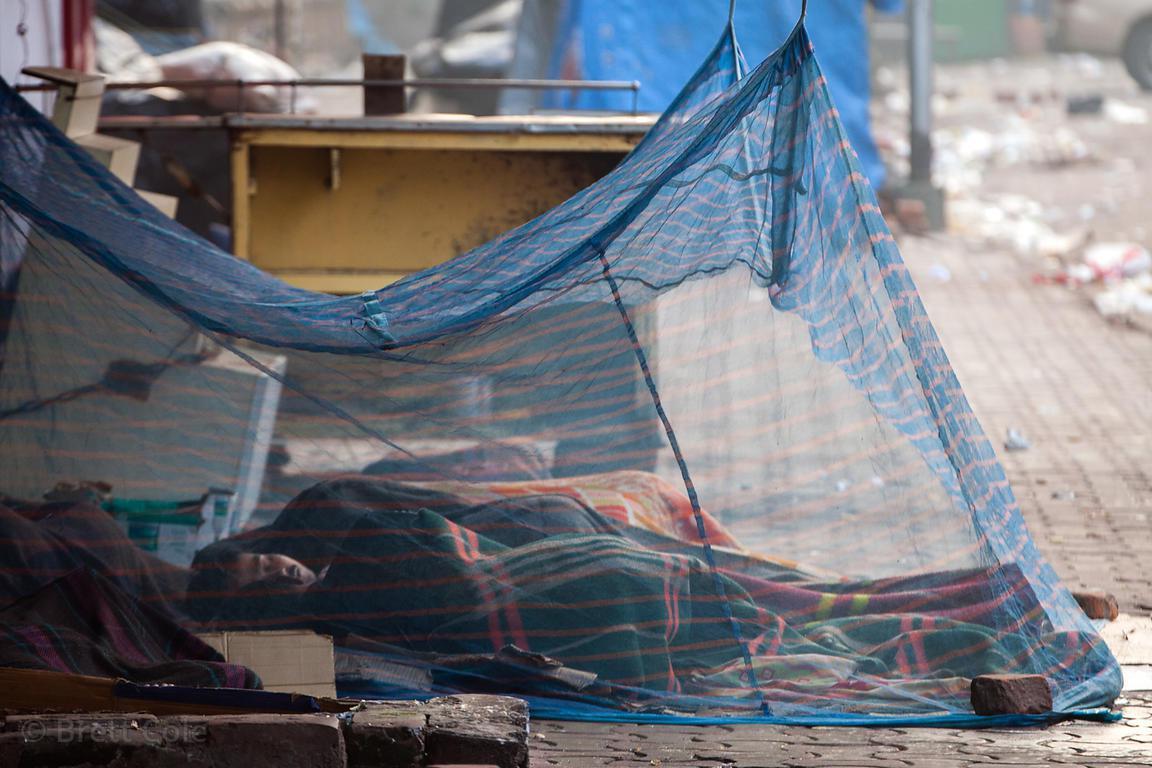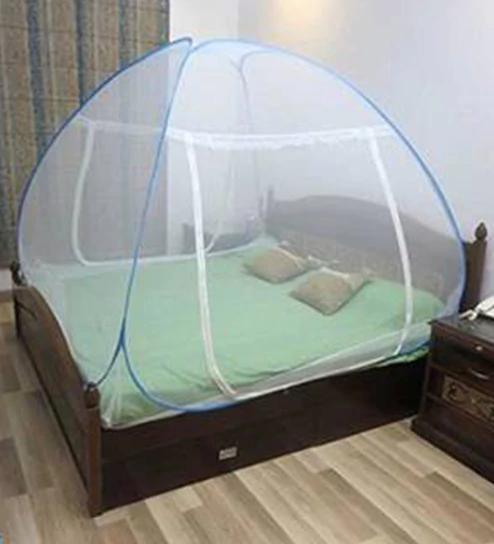The first image is the image on the left, the second image is the image on the right. Given the left and right images, does the statement "Each image shows a gauzy white canopy that suspends from above to surround a mattress, and at least one image shows two people lying under the canopy." hold true? Answer yes or no. No. The first image is the image on the left, the second image is the image on the right. For the images shown, is this caption "The left and right image contains the same number of circle canopies." true? Answer yes or no. No. 